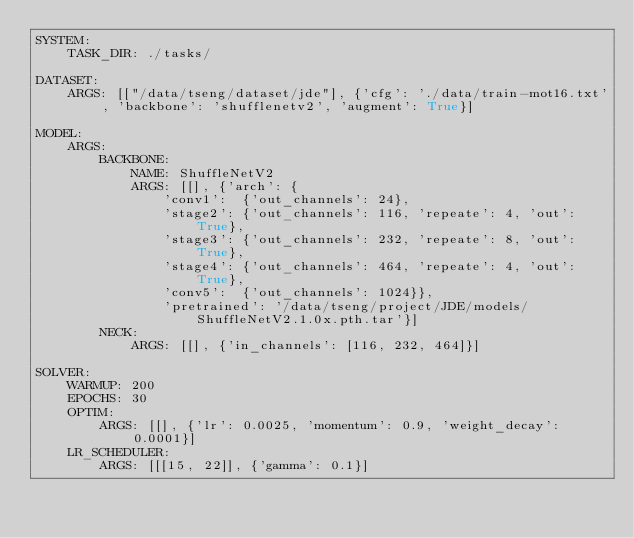<code> <loc_0><loc_0><loc_500><loc_500><_YAML_>SYSTEM:
    TASK_DIR: ./tasks/

DATASET:
    ARGS: [["/data/tseng/dataset/jde"], {'cfg': './data/train-mot16.txt', 'backbone': 'shufflenetv2', 'augment': True}]

MODEL:
    ARGS:
        BACKBONE:
            NAME: ShuffleNetV2
            ARGS: [[], {'arch': {
                'conv1':  {'out_channels': 24},
                'stage2': {'out_channels': 116, 'repeate': 4, 'out': True},
                'stage3': {'out_channels': 232, 'repeate': 8, 'out': True},
                'stage4': {'out_channels': 464, 'repeate': 4, 'out': True},
                'conv5':  {'out_channels': 1024}},
                'pretrained': '/data/tseng/project/JDE/models/ShuffleNetV2.1.0x.pth.tar'}]
        NECK:
            ARGS: [[], {'in_channels': [116, 232, 464]}]

SOLVER:
    WARMUP: 200
    EPOCHS: 30
    OPTIM:
        ARGS: [[], {'lr': 0.0025, 'momentum': 0.9, 'weight_decay': 0.0001}]
    LR_SCHEDULER:
        ARGS: [[[15, 22]], {'gamma': 0.1}]</code> 